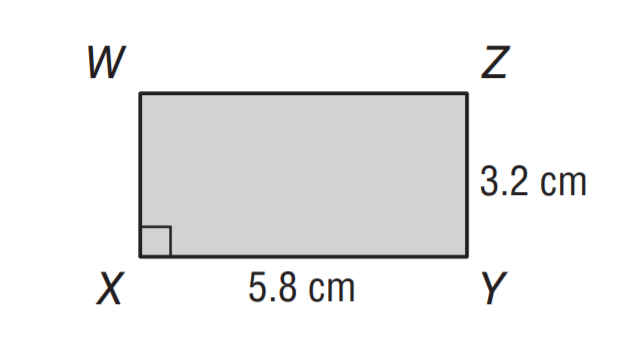Question: What is the area of rectangle W X Y Z?
Choices:
A. 18.6
B. 20.4
C. 21.2
D. 22.8
Answer with the letter. Answer: A 